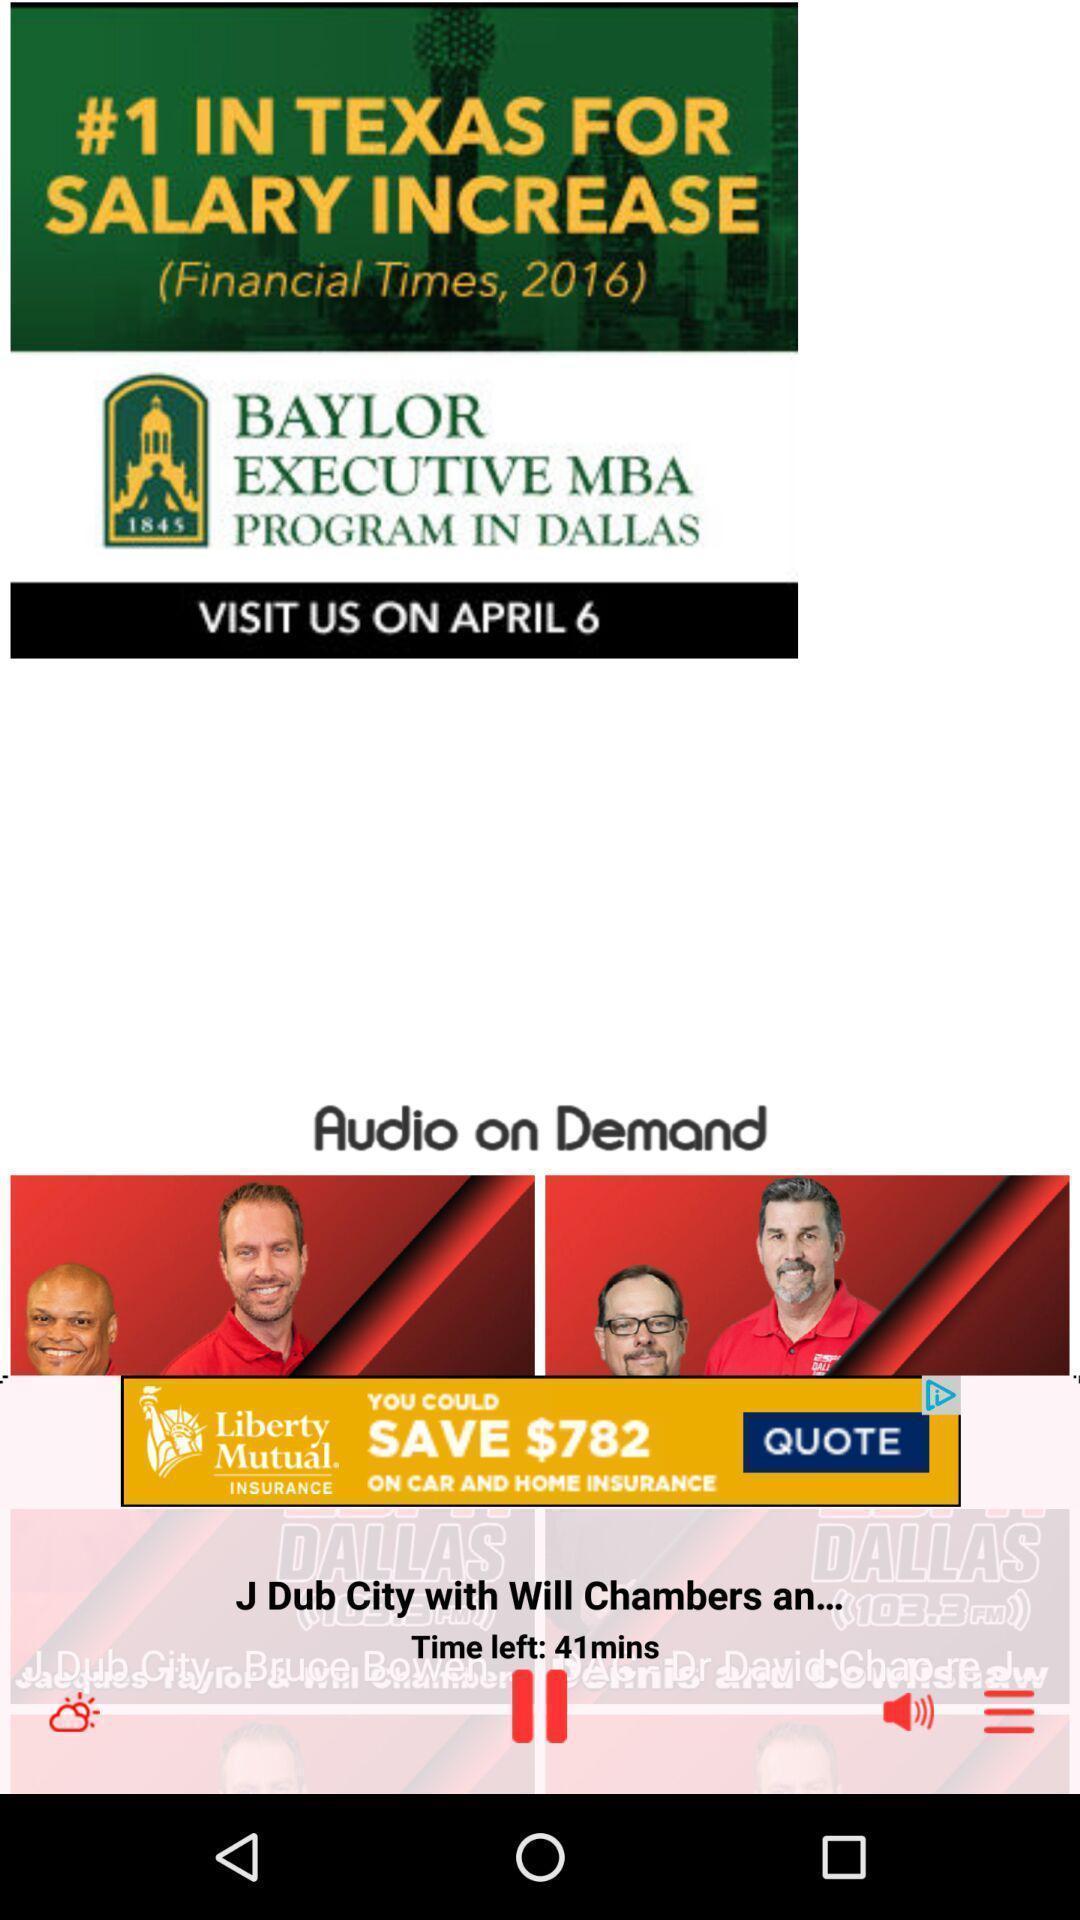Give me a summary of this screen capture. Texas salary increase in financial times. 